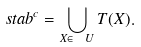Convert formula to latex. <formula><loc_0><loc_0><loc_500><loc_500>\ s t a b ^ { c } = \bigcup _ { X \in \ U } T ( X ) .</formula> 